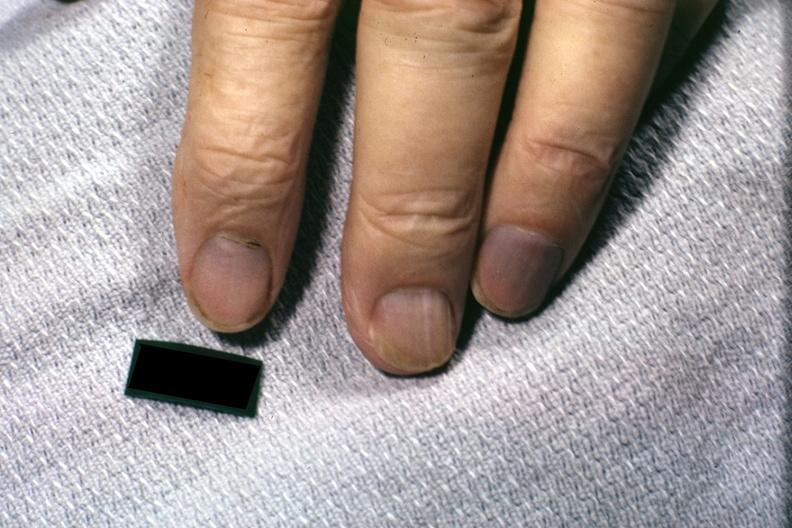does this image show excellent example of cyanotic nail beds?
Answer the question using a single word or phrase. Yes 